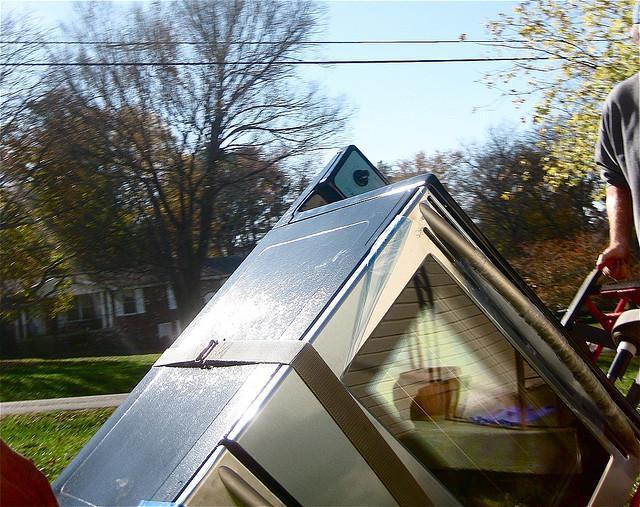How many people are visible?
Give a very brief answer. 1. How many elephants are under a tree branch?
Give a very brief answer. 0. 